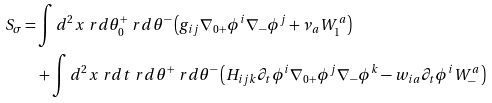<formula> <loc_0><loc_0><loc_500><loc_500>S _ { \sigma } = & \int d { ^ { 2 } x \ r d \theta _ { 0 } ^ { + } \ r d \theta ^ { - } } \left ( g _ { i j } \nabla _ { 0 + } \phi ^ { i } \nabla _ { - } \phi ^ { j } + \nu _ { a } W ^ { a } _ { 1 } \right ) \\ & + \int d { ^ { 2 } x \ r d t \ r d \theta ^ { + } \ r d \theta ^ { - } } \left ( H _ { i j k } \partial _ { t } \phi ^ { i } \nabla _ { 0 + } \phi ^ { j } \nabla _ { - } \phi ^ { k } - w _ { i a } \partial _ { t } \phi ^ { i } W _ { - } ^ { a } \right )</formula> 